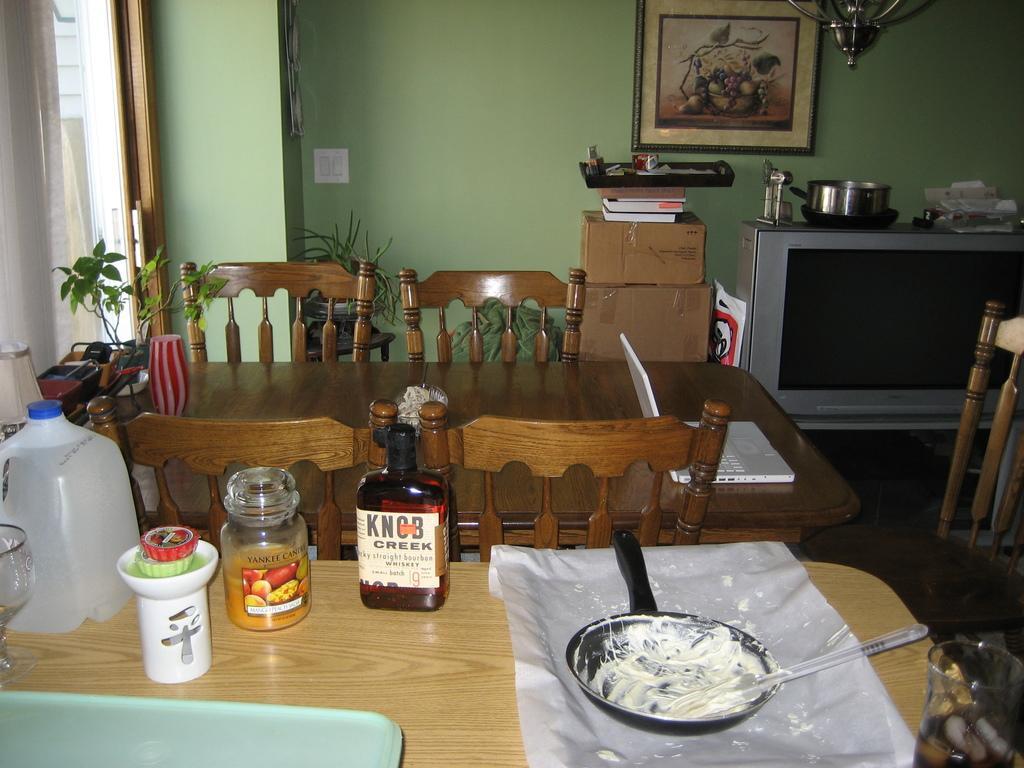Describe this image in one or two sentences. In this image we can see a dining table,chair,lamp,flower pot,glass,jar,tray and pan. The frame and a switchboard is attached to the wall. There are cardboard box and a tray book. There is a television in the room. 